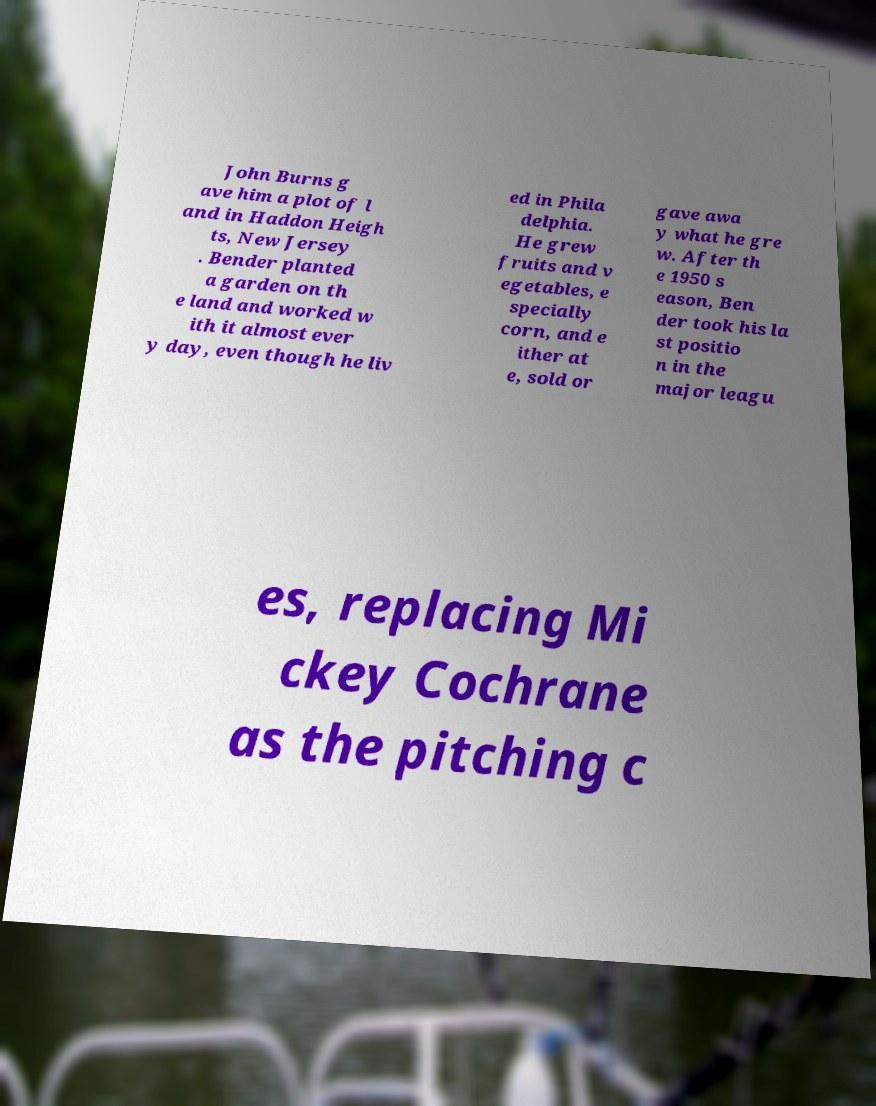For documentation purposes, I need the text within this image transcribed. Could you provide that? John Burns g ave him a plot of l and in Haddon Heigh ts, New Jersey . Bender planted a garden on th e land and worked w ith it almost ever y day, even though he liv ed in Phila delphia. He grew fruits and v egetables, e specially corn, and e ither at e, sold or gave awa y what he gre w. After th e 1950 s eason, Ben der took his la st positio n in the major leagu es, replacing Mi ckey Cochrane as the pitching c 